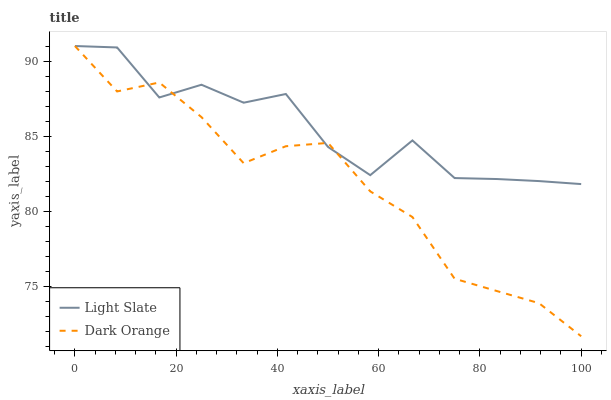Does Dark Orange have the minimum area under the curve?
Answer yes or no. Yes. Does Light Slate have the maximum area under the curve?
Answer yes or no. Yes. Does Dark Orange have the maximum area under the curve?
Answer yes or no. No. Is Dark Orange the smoothest?
Answer yes or no. Yes. Is Light Slate the roughest?
Answer yes or no. Yes. Is Dark Orange the roughest?
Answer yes or no. No. Does Dark Orange have the lowest value?
Answer yes or no. Yes. Does Dark Orange have the highest value?
Answer yes or no. Yes. Does Dark Orange intersect Light Slate?
Answer yes or no. Yes. Is Dark Orange less than Light Slate?
Answer yes or no. No. Is Dark Orange greater than Light Slate?
Answer yes or no. No. 